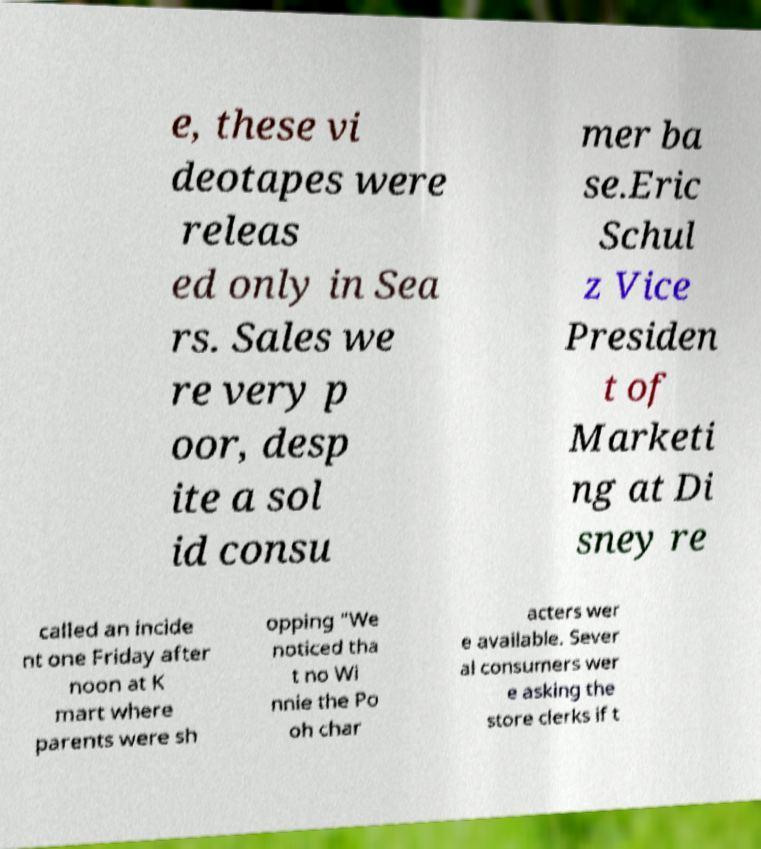Can you accurately transcribe the text from the provided image for me? e, these vi deotapes were releas ed only in Sea rs. Sales we re very p oor, desp ite a sol id consu mer ba se.Eric Schul z Vice Presiden t of Marketi ng at Di sney re called an incide nt one Friday after noon at K mart where parents were sh opping "We noticed tha t no Wi nnie the Po oh char acters wer e available. Sever al consumers wer e asking the store clerks if t 